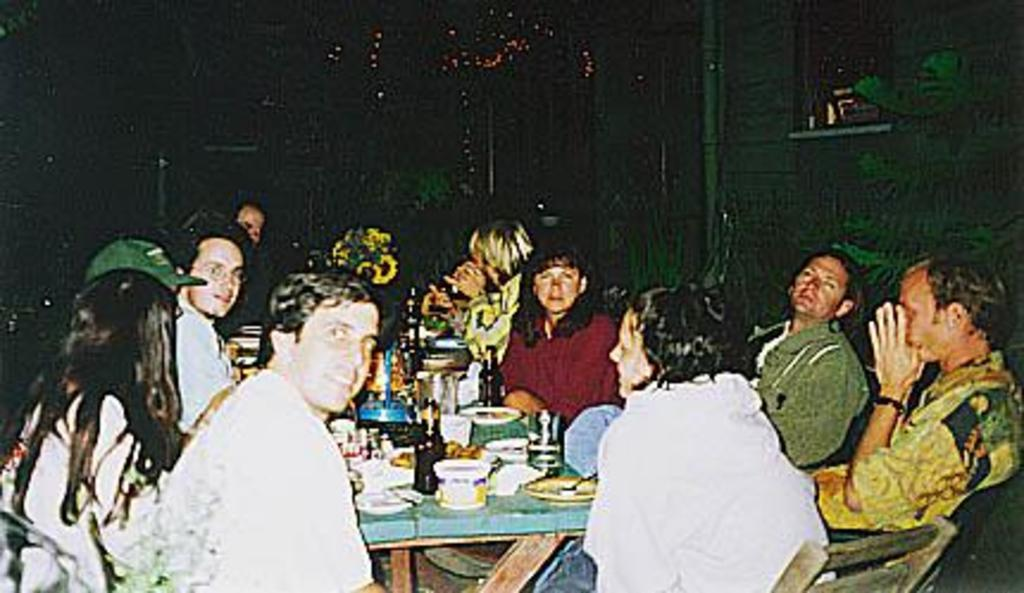What are the people in the image doing? The people in the image are sitting on chairs. What is in front of the people? There is a table in front of the people. What can be seen on the table? There are wine bottles, glasses, cans, plates, and food items on the table. What type of jar is being used in the competition in the image? There is no jar or competition present in the image. How much salt is on the table in the image? There is no salt visible on the table in the image. 